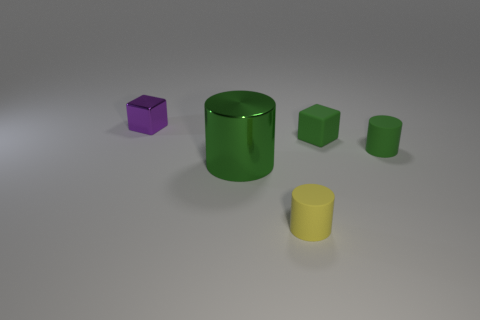Add 5 small yellow things. How many objects exist? 10 Subtract all cylinders. How many objects are left? 2 Add 5 big blue balls. How many big blue balls exist? 5 Subtract 0 cyan balls. How many objects are left? 5 Subtract all green cylinders. Subtract all tiny green things. How many objects are left? 1 Add 5 purple shiny things. How many purple shiny things are left? 6 